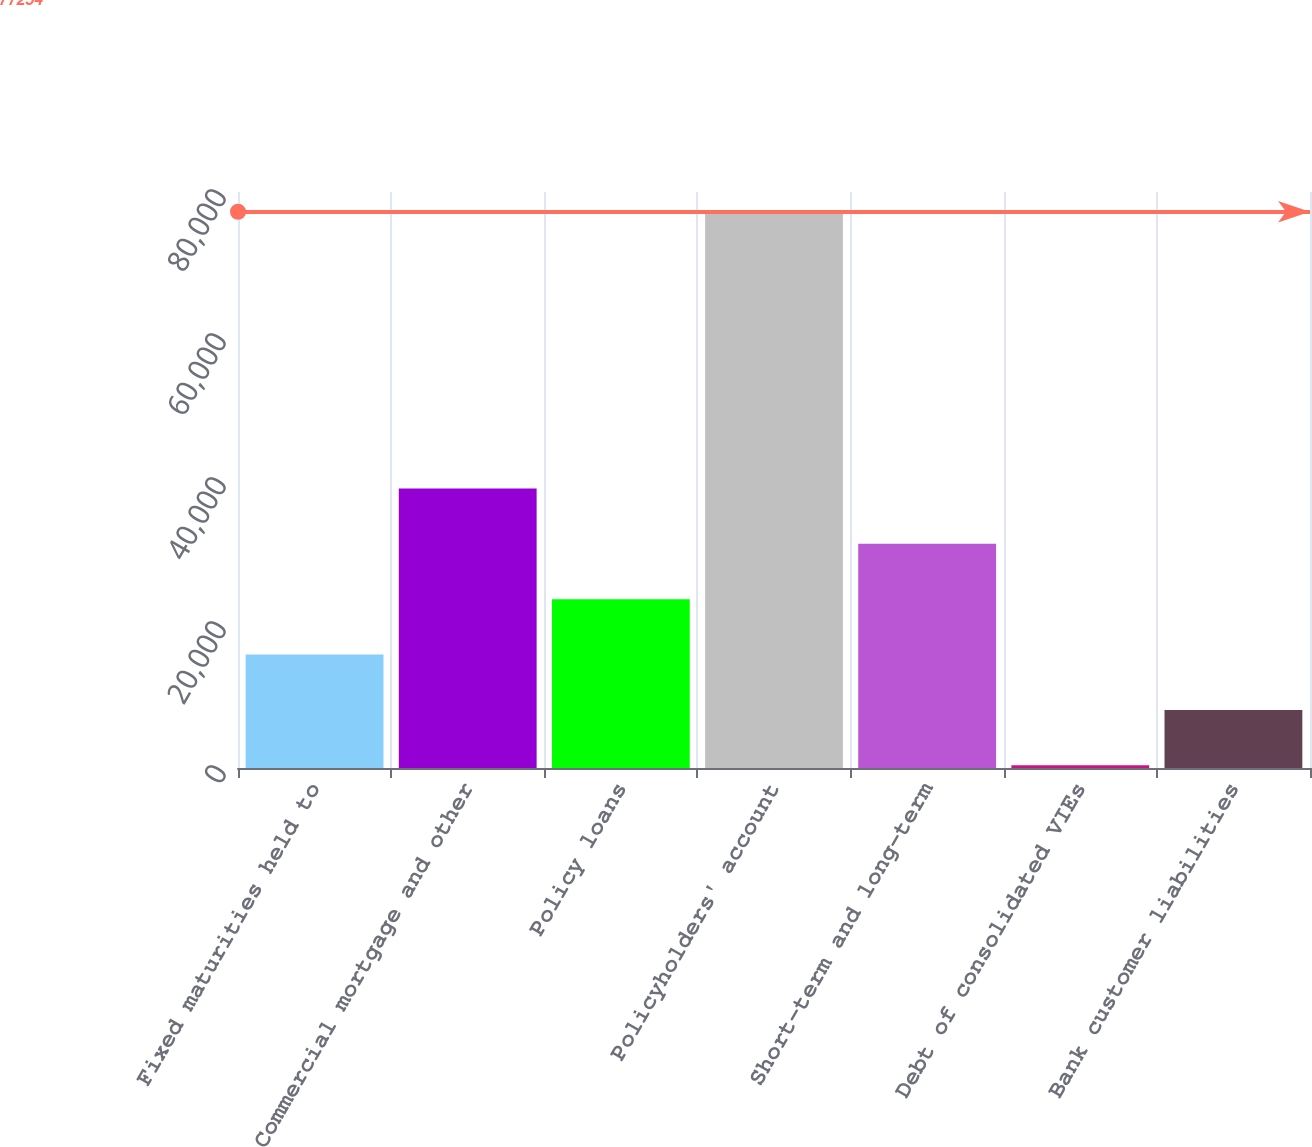Convert chart. <chart><loc_0><loc_0><loc_500><loc_500><bar_chart><fcel>Fixed maturities held to<fcel>Commercial mortgage and other<fcel>Policy loans<fcel>Policyholders' account<fcel>Short-term and long-term<fcel>Debt of consolidated VIEs<fcel>Bank customer liabilities<nl><fcel>15756.4<fcel>38818<fcel>23443.6<fcel>77254<fcel>31130.8<fcel>382<fcel>8069.2<nl></chart> 